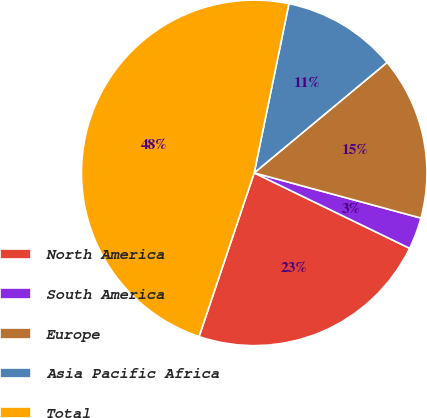Convert chart to OTSL. <chart><loc_0><loc_0><loc_500><loc_500><pie_chart><fcel>North America<fcel>South America<fcel>Europe<fcel>Asia Pacific Africa<fcel>Total<nl><fcel>22.98%<fcel>2.98%<fcel>15.25%<fcel>10.74%<fcel>48.05%<nl></chart> 